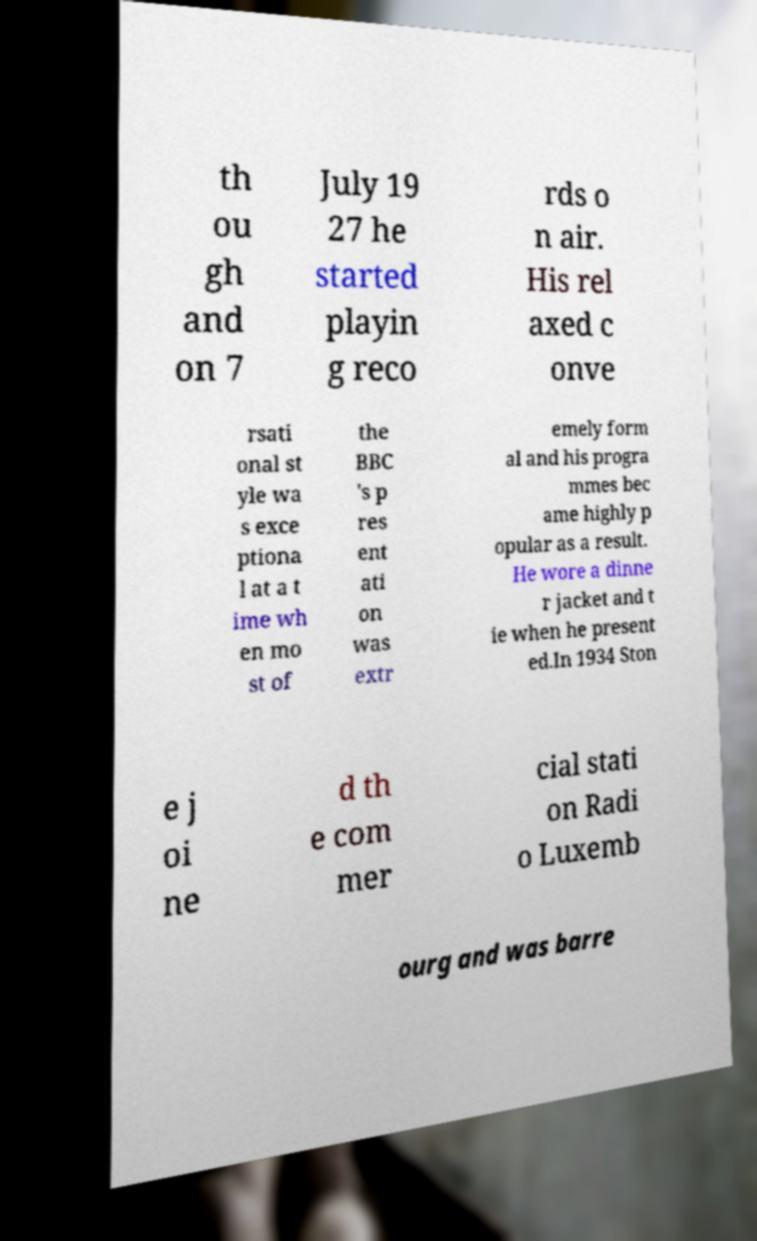Can you accurately transcribe the text from the provided image for me? th ou gh and on 7 July 19 27 he started playin g reco rds o n air. His rel axed c onve rsati onal st yle wa s exce ptiona l at a t ime wh en mo st of the BBC 's p res ent ati on was extr emely form al and his progra mmes bec ame highly p opular as a result. He wore a dinne r jacket and t ie when he present ed.In 1934 Ston e j oi ne d th e com mer cial stati on Radi o Luxemb ourg and was barre 